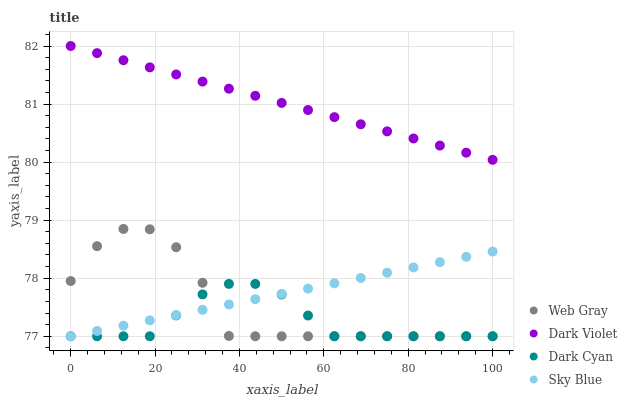Does Dark Cyan have the minimum area under the curve?
Answer yes or no. Yes. Does Dark Violet have the maximum area under the curve?
Answer yes or no. Yes. Does Sky Blue have the minimum area under the curve?
Answer yes or no. No. Does Sky Blue have the maximum area under the curve?
Answer yes or no. No. Is Dark Violet the smoothest?
Answer yes or no. Yes. Is Web Gray the roughest?
Answer yes or no. Yes. Is Sky Blue the smoothest?
Answer yes or no. No. Is Sky Blue the roughest?
Answer yes or no. No. Does Dark Cyan have the lowest value?
Answer yes or no. Yes. Does Dark Violet have the lowest value?
Answer yes or no. No. Does Dark Violet have the highest value?
Answer yes or no. Yes. Does Sky Blue have the highest value?
Answer yes or no. No. Is Web Gray less than Dark Violet?
Answer yes or no. Yes. Is Dark Violet greater than Dark Cyan?
Answer yes or no. Yes. Does Sky Blue intersect Web Gray?
Answer yes or no. Yes. Is Sky Blue less than Web Gray?
Answer yes or no. No. Is Sky Blue greater than Web Gray?
Answer yes or no. No. Does Web Gray intersect Dark Violet?
Answer yes or no. No. 